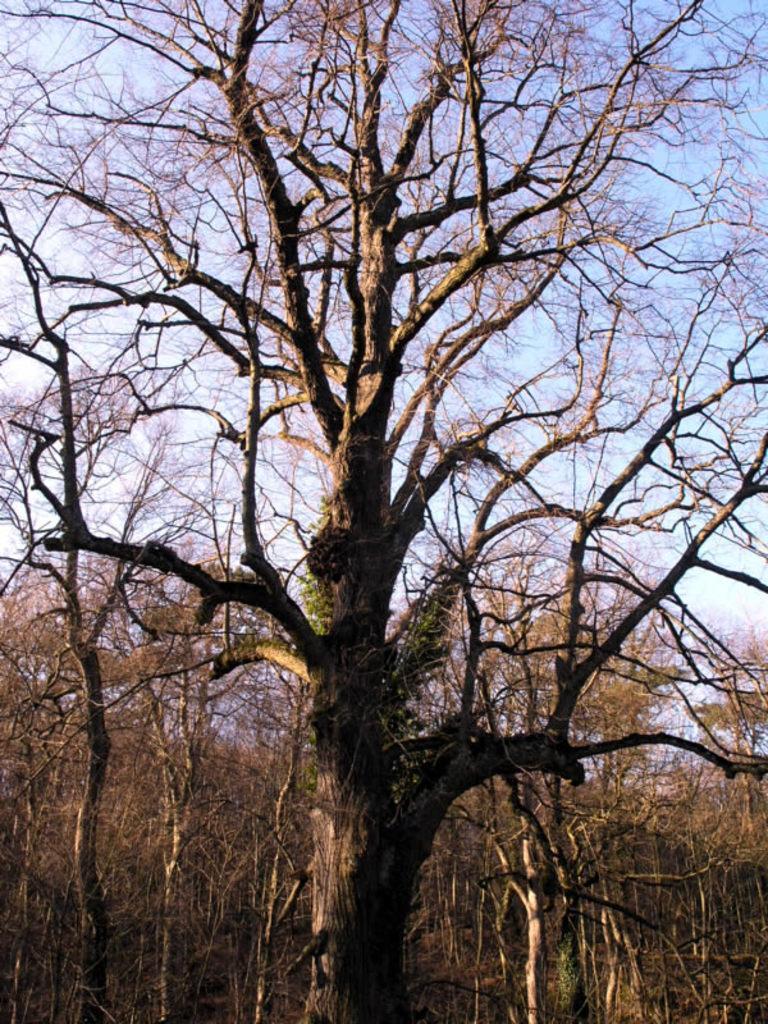In one or two sentences, can you explain what this image depicts? In this image we can see bare trees. In the background there is sky. 